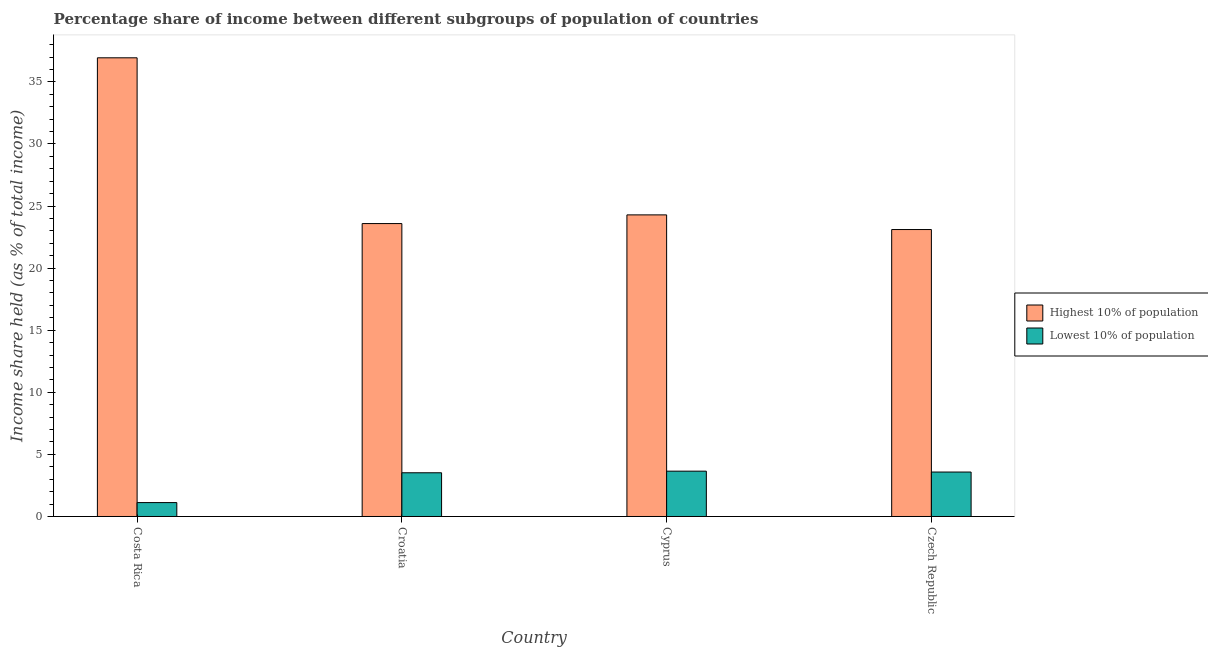How many different coloured bars are there?
Offer a very short reply. 2. How many groups of bars are there?
Ensure brevity in your answer.  4. Are the number of bars per tick equal to the number of legend labels?
Your answer should be very brief. Yes. In how many cases, is the number of bars for a given country not equal to the number of legend labels?
Provide a short and direct response. 0. What is the income share held by highest 10% of the population in Cyprus?
Keep it short and to the point. 24.29. Across all countries, what is the maximum income share held by highest 10% of the population?
Make the answer very short. 36.94. Across all countries, what is the minimum income share held by highest 10% of the population?
Make the answer very short. 23.11. In which country was the income share held by highest 10% of the population maximum?
Your answer should be very brief. Costa Rica. In which country was the income share held by highest 10% of the population minimum?
Your answer should be compact. Czech Republic. What is the total income share held by highest 10% of the population in the graph?
Keep it short and to the point. 107.93. What is the difference between the income share held by lowest 10% of the population in Cyprus and that in Czech Republic?
Give a very brief answer. 0.07. What is the difference between the income share held by highest 10% of the population in Costa Rica and the income share held by lowest 10% of the population in Czech Republic?
Ensure brevity in your answer.  33.36. What is the average income share held by highest 10% of the population per country?
Provide a succinct answer. 26.98. What is the difference between the income share held by highest 10% of the population and income share held by lowest 10% of the population in Costa Rica?
Provide a succinct answer. 35.82. In how many countries, is the income share held by lowest 10% of the population greater than 10 %?
Provide a short and direct response. 0. What is the ratio of the income share held by lowest 10% of the population in Costa Rica to that in Croatia?
Offer a very short reply. 0.32. Is the income share held by highest 10% of the population in Cyprus less than that in Czech Republic?
Offer a very short reply. No. Is the difference between the income share held by lowest 10% of the population in Costa Rica and Cyprus greater than the difference between the income share held by highest 10% of the population in Costa Rica and Cyprus?
Your response must be concise. No. What is the difference between the highest and the second highest income share held by lowest 10% of the population?
Give a very brief answer. 0.07. What is the difference between the highest and the lowest income share held by lowest 10% of the population?
Your response must be concise. 2.53. What does the 2nd bar from the left in Cyprus represents?
Your answer should be very brief. Lowest 10% of population. What does the 2nd bar from the right in Cyprus represents?
Give a very brief answer. Highest 10% of population. What is the difference between two consecutive major ticks on the Y-axis?
Keep it short and to the point. 5. Are the values on the major ticks of Y-axis written in scientific E-notation?
Your answer should be very brief. No. Does the graph contain any zero values?
Give a very brief answer. No. Does the graph contain grids?
Your answer should be compact. No. Where does the legend appear in the graph?
Your answer should be very brief. Center right. What is the title of the graph?
Offer a very short reply. Percentage share of income between different subgroups of population of countries. Does "Public funds" appear as one of the legend labels in the graph?
Provide a succinct answer. No. What is the label or title of the Y-axis?
Provide a succinct answer. Income share held (as % of total income). What is the Income share held (as % of total income) in Highest 10% of population in Costa Rica?
Provide a succinct answer. 36.94. What is the Income share held (as % of total income) in Lowest 10% of population in Costa Rica?
Your answer should be very brief. 1.12. What is the Income share held (as % of total income) of Highest 10% of population in Croatia?
Keep it short and to the point. 23.59. What is the Income share held (as % of total income) in Lowest 10% of population in Croatia?
Make the answer very short. 3.52. What is the Income share held (as % of total income) of Highest 10% of population in Cyprus?
Your answer should be very brief. 24.29. What is the Income share held (as % of total income) of Lowest 10% of population in Cyprus?
Give a very brief answer. 3.65. What is the Income share held (as % of total income) of Highest 10% of population in Czech Republic?
Your answer should be compact. 23.11. What is the Income share held (as % of total income) in Lowest 10% of population in Czech Republic?
Provide a succinct answer. 3.58. Across all countries, what is the maximum Income share held (as % of total income) in Highest 10% of population?
Your answer should be compact. 36.94. Across all countries, what is the maximum Income share held (as % of total income) of Lowest 10% of population?
Make the answer very short. 3.65. Across all countries, what is the minimum Income share held (as % of total income) of Highest 10% of population?
Offer a terse response. 23.11. Across all countries, what is the minimum Income share held (as % of total income) of Lowest 10% of population?
Your response must be concise. 1.12. What is the total Income share held (as % of total income) of Highest 10% of population in the graph?
Keep it short and to the point. 107.93. What is the total Income share held (as % of total income) in Lowest 10% of population in the graph?
Make the answer very short. 11.87. What is the difference between the Income share held (as % of total income) of Highest 10% of population in Costa Rica and that in Croatia?
Keep it short and to the point. 13.35. What is the difference between the Income share held (as % of total income) in Lowest 10% of population in Costa Rica and that in Croatia?
Your answer should be compact. -2.4. What is the difference between the Income share held (as % of total income) in Highest 10% of population in Costa Rica and that in Cyprus?
Ensure brevity in your answer.  12.65. What is the difference between the Income share held (as % of total income) in Lowest 10% of population in Costa Rica and that in Cyprus?
Offer a terse response. -2.53. What is the difference between the Income share held (as % of total income) in Highest 10% of population in Costa Rica and that in Czech Republic?
Offer a terse response. 13.83. What is the difference between the Income share held (as % of total income) of Lowest 10% of population in Costa Rica and that in Czech Republic?
Your response must be concise. -2.46. What is the difference between the Income share held (as % of total income) in Highest 10% of population in Croatia and that in Cyprus?
Make the answer very short. -0.7. What is the difference between the Income share held (as % of total income) of Lowest 10% of population in Croatia and that in Cyprus?
Provide a succinct answer. -0.13. What is the difference between the Income share held (as % of total income) of Highest 10% of population in Croatia and that in Czech Republic?
Ensure brevity in your answer.  0.48. What is the difference between the Income share held (as % of total income) of Lowest 10% of population in Croatia and that in Czech Republic?
Give a very brief answer. -0.06. What is the difference between the Income share held (as % of total income) of Highest 10% of population in Cyprus and that in Czech Republic?
Provide a short and direct response. 1.18. What is the difference between the Income share held (as % of total income) in Lowest 10% of population in Cyprus and that in Czech Republic?
Provide a succinct answer. 0.07. What is the difference between the Income share held (as % of total income) of Highest 10% of population in Costa Rica and the Income share held (as % of total income) of Lowest 10% of population in Croatia?
Keep it short and to the point. 33.42. What is the difference between the Income share held (as % of total income) in Highest 10% of population in Costa Rica and the Income share held (as % of total income) in Lowest 10% of population in Cyprus?
Provide a short and direct response. 33.29. What is the difference between the Income share held (as % of total income) in Highest 10% of population in Costa Rica and the Income share held (as % of total income) in Lowest 10% of population in Czech Republic?
Your answer should be compact. 33.36. What is the difference between the Income share held (as % of total income) in Highest 10% of population in Croatia and the Income share held (as % of total income) in Lowest 10% of population in Cyprus?
Your answer should be very brief. 19.94. What is the difference between the Income share held (as % of total income) in Highest 10% of population in Croatia and the Income share held (as % of total income) in Lowest 10% of population in Czech Republic?
Keep it short and to the point. 20.01. What is the difference between the Income share held (as % of total income) of Highest 10% of population in Cyprus and the Income share held (as % of total income) of Lowest 10% of population in Czech Republic?
Provide a short and direct response. 20.71. What is the average Income share held (as % of total income) of Highest 10% of population per country?
Make the answer very short. 26.98. What is the average Income share held (as % of total income) of Lowest 10% of population per country?
Offer a very short reply. 2.97. What is the difference between the Income share held (as % of total income) in Highest 10% of population and Income share held (as % of total income) in Lowest 10% of population in Costa Rica?
Offer a terse response. 35.82. What is the difference between the Income share held (as % of total income) of Highest 10% of population and Income share held (as % of total income) of Lowest 10% of population in Croatia?
Your response must be concise. 20.07. What is the difference between the Income share held (as % of total income) of Highest 10% of population and Income share held (as % of total income) of Lowest 10% of population in Cyprus?
Make the answer very short. 20.64. What is the difference between the Income share held (as % of total income) of Highest 10% of population and Income share held (as % of total income) of Lowest 10% of population in Czech Republic?
Provide a succinct answer. 19.53. What is the ratio of the Income share held (as % of total income) of Highest 10% of population in Costa Rica to that in Croatia?
Offer a terse response. 1.57. What is the ratio of the Income share held (as % of total income) in Lowest 10% of population in Costa Rica to that in Croatia?
Offer a very short reply. 0.32. What is the ratio of the Income share held (as % of total income) of Highest 10% of population in Costa Rica to that in Cyprus?
Give a very brief answer. 1.52. What is the ratio of the Income share held (as % of total income) in Lowest 10% of population in Costa Rica to that in Cyprus?
Provide a succinct answer. 0.31. What is the ratio of the Income share held (as % of total income) of Highest 10% of population in Costa Rica to that in Czech Republic?
Make the answer very short. 1.6. What is the ratio of the Income share held (as % of total income) of Lowest 10% of population in Costa Rica to that in Czech Republic?
Offer a terse response. 0.31. What is the ratio of the Income share held (as % of total income) in Highest 10% of population in Croatia to that in Cyprus?
Your response must be concise. 0.97. What is the ratio of the Income share held (as % of total income) of Lowest 10% of population in Croatia to that in Cyprus?
Offer a very short reply. 0.96. What is the ratio of the Income share held (as % of total income) of Highest 10% of population in Croatia to that in Czech Republic?
Keep it short and to the point. 1.02. What is the ratio of the Income share held (as % of total income) in Lowest 10% of population in Croatia to that in Czech Republic?
Provide a succinct answer. 0.98. What is the ratio of the Income share held (as % of total income) in Highest 10% of population in Cyprus to that in Czech Republic?
Your answer should be very brief. 1.05. What is the ratio of the Income share held (as % of total income) in Lowest 10% of population in Cyprus to that in Czech Republic?
Give a very brief answer. 1.02. What is the difference between the highest and the second highest Income share held (as % of total income) in Highest 10% of population?
Keep it short and to the point. 12.65. What is the difference between the highest and the second highest Income share held (as % of total income) of Lowest 10% of population?
Give a very brief answer. 0.07. What is the difference between the highest and the lowest Income share held (as % of total income) in Highest 10% of population?
Give a very brief answer. 13.83. What is the difference between the highest and the lowest Income share held (as % of total income) of Lowest 10% of population?
Give a very brief answer. 2.53. 